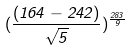<formula> <loc_0><loc_0><loc_500><loc_500>( \frac { ( 1 6 4 - 2 4 2 ) } { \sqrt { 5 } } ) ^ { \frac { 2 8 3 } { 9 } }</formula> 